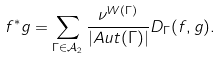<formula> <loc_0><loc_0><loc_500><loc_500>f ^ { * } g = \sum _ { \Gamma \in { \mathcal { A } } _ { 2 } } \frac { \nu ^ { W ( \Gamma ) } } { | A u t ( \Gamma ) | } D _ { \Gamma } ( f , g ) .</formula> 